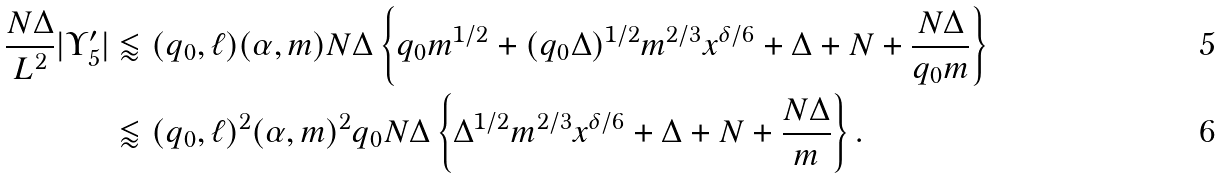Convert formula to latex. <formula><loc_0><loc_0><loc_500><loc_500>\frac { N \Delta } { L ^ { 2 } } | \Upsilon ^ { \prime } _ { 5 } | & \lessapprox ( q _ { 0 } , \ell ) ( \alpha , m ) N \Delta \left \{ q _ { 0 } m ^ { 1 / 2 } + ( q _ { 0 } \Delta ) ^ { 1 / 2 } m ^ { 2 / 3 } x ^ { \delta / 6 } + \Delta + N + \frac { N \Delta } { q _ { 0 } m } \right \} \\ & \lessapprox ( q _ { 0 } , \ell ) ^ { 2 } ( \alpha , m ) ^ { 2 } q _ { 0 } N \Delta \left \{ \Delta ^ { 1 / 2 } m ^ { 2 / 3 } x ^ { \delta / 6 } + \Delta + N + \frac { N \Delta } { m } \right \} .</formula> 